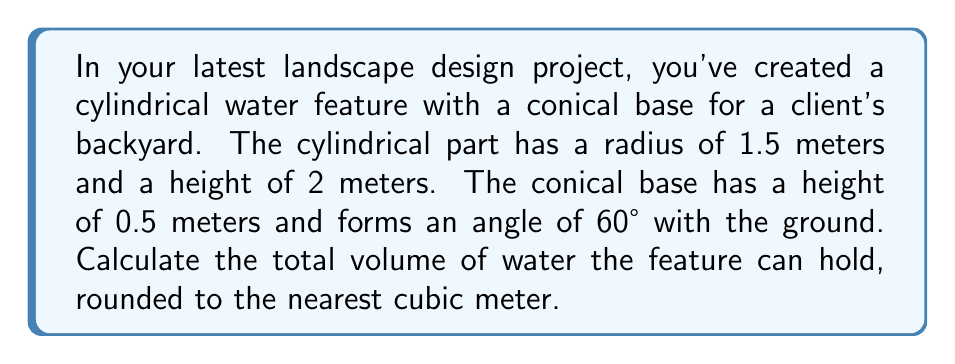Solve this math problem. To solve this problem, we need to calculate the volumes of both the cylindrical part and the conical base, then add them together.

1. Volume of the cylindrical part:
   The formula for the volume of a cylinder is $V_c = \pi r^2 h$
   $$V_c = \pi \cdot (1.5 \text{ m})^2 \cdot 2 \text{ m} = 4.5\pi \text{ m}^3$$

2. Volume of the conical base:
   First, we need to find the radius of the base of the cone. We can use trigonometry:
   $$\tan 60° = \frac{\text{radius}}{\text{height}} = \frac{r}{0.5}$$
   $$r = 0.5 \tan 60° = 0.5 \cdot \sqrt{3} \approx 0.866 \text{ m}$$

   Now we can use the formula for the volume of a cone: $V_n = \frac{1}{3}\pi r^2 h$
   $$V_n = \frac{1}{3}\pi \cdot (0.866 \text{ m})^2 \cdot 0.5 \text{ m} \approx 0.125\pi \text{ m}^3$$

3. Total volume:
   $$V_{total} = V_c + V_n = 4.5\pi \text{ m}^3 + 0.125\pi \text{ m}^3 = 4.625\pi \text{ m}^3$$

   Converting to a numerical value:
   $$V_{total} = 4.625\pi \text{ m}^3 \approx 14.53 \text{ m}^3$$

Rounding to the nearest cubic meter gives us 15 m³.
Answer: 15 m³ 